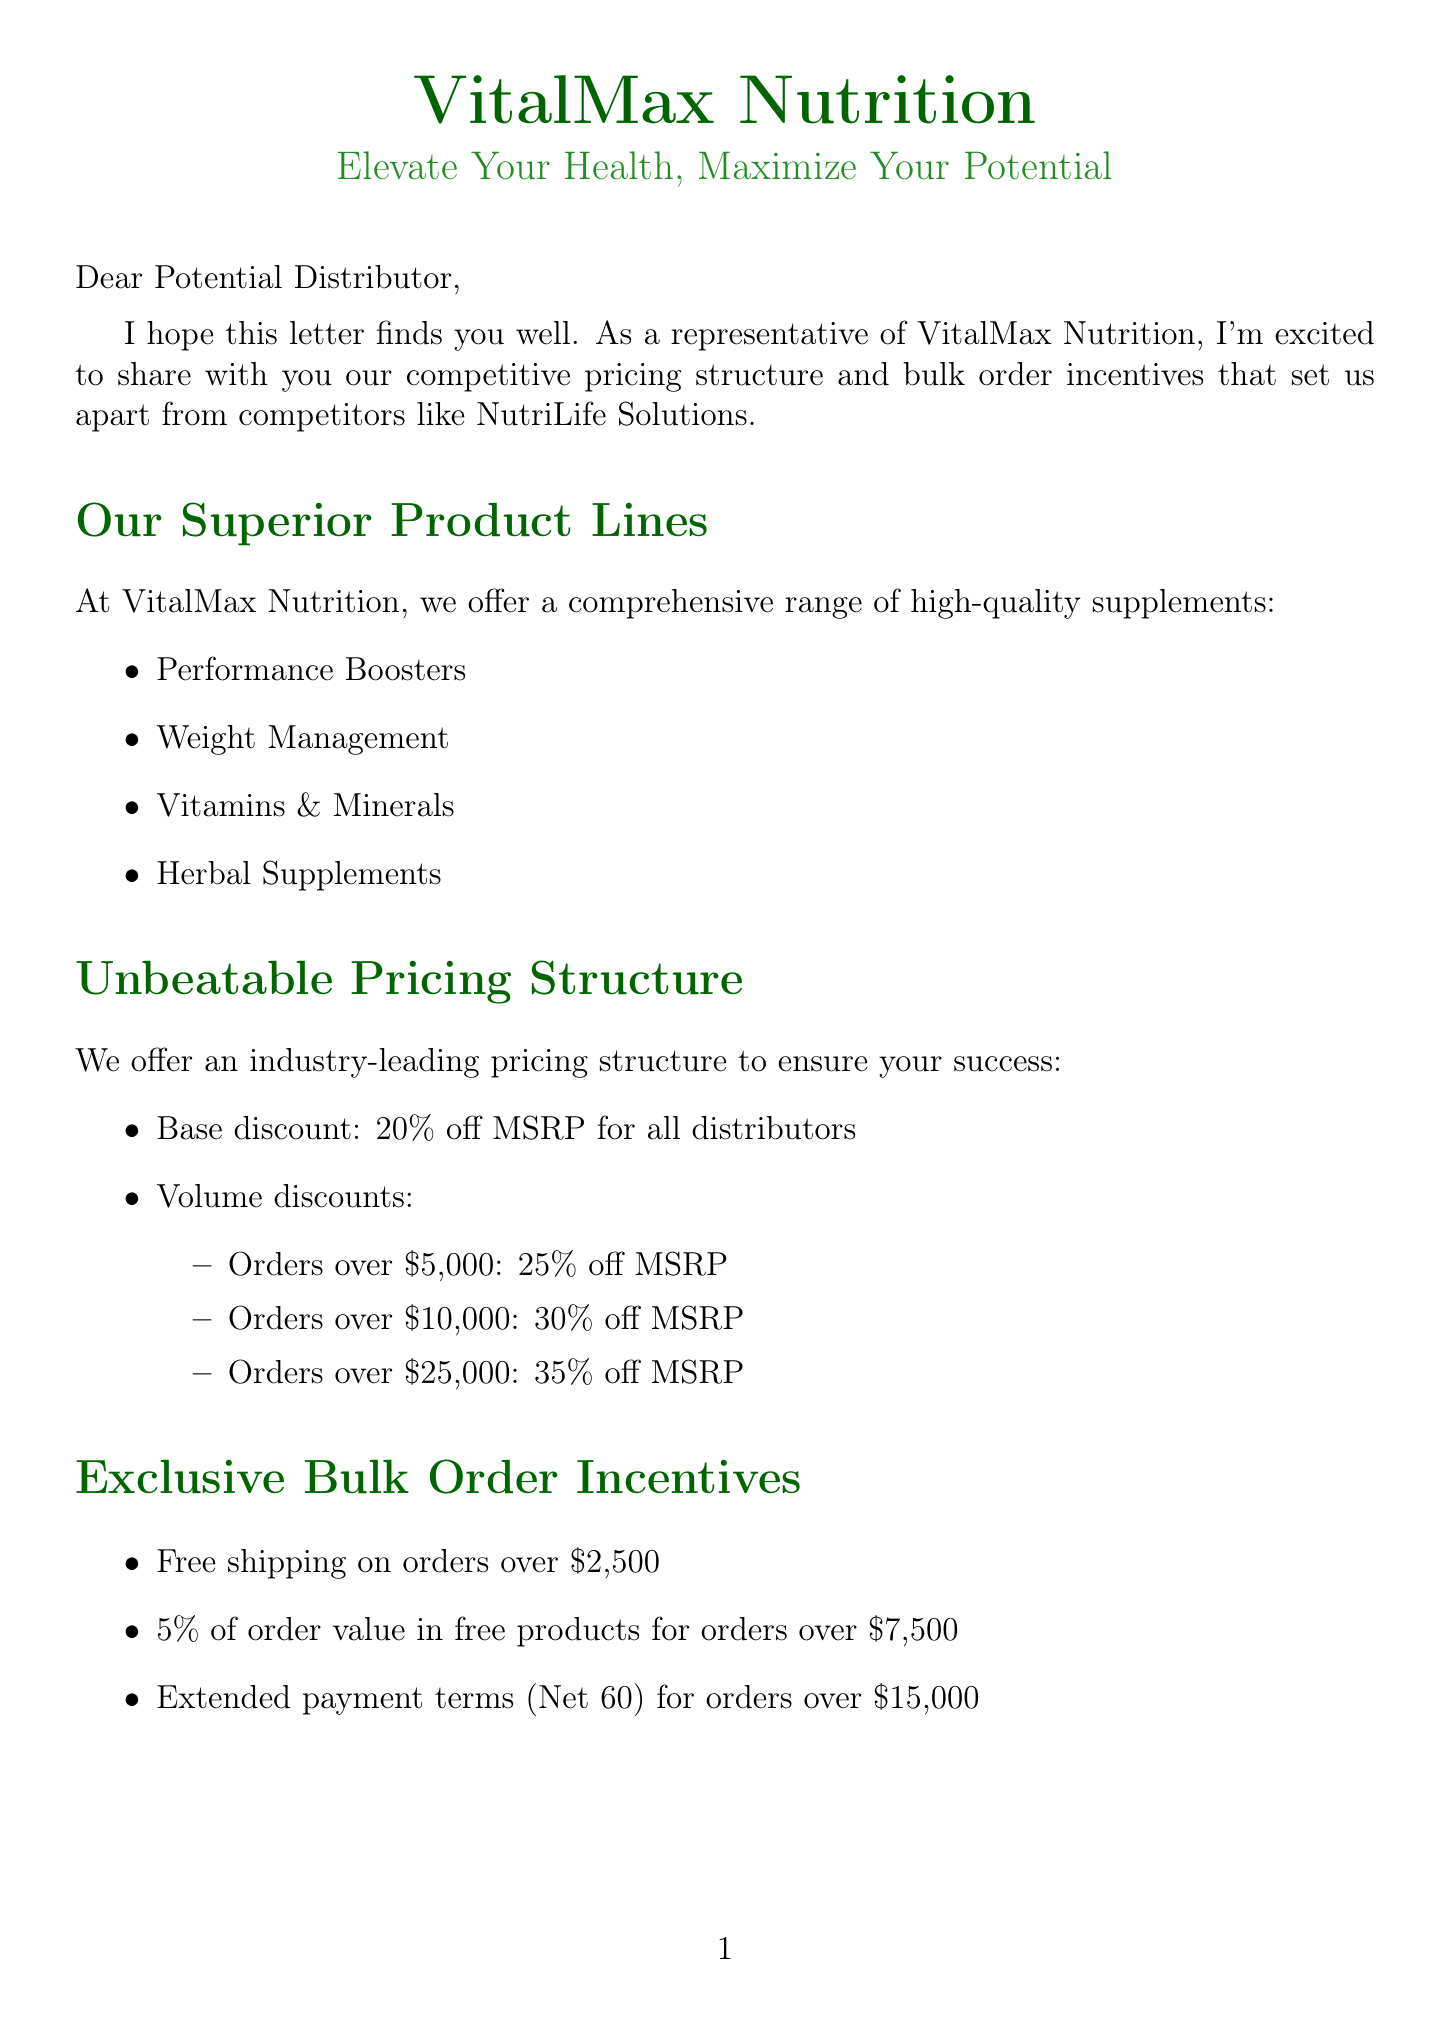What is the base discount for distributors? The base discount for all distributors is stated in the pricing structure section of the document.
Answer: 20% off MSRP What is the discount for orders over $10,000? The volume discounts section outlines the specific discounts based on order thresholds, including the one for over $10,000.
Answer: 30% off MSRP What is the threshold for free shipping? The bulk order incentives section mentions the specific amount that qualifies for free shipping.
Answer: Orders over $2,500 Who is the sales representative mentioned in the contact information? The document explicitly lists the sales representative's name in the contact information section.
Answer: Michael Chen What certification ensures products are tested by a third-party for purity and potency? The quality assurance section highlights the importance of certifications and testing, including the one that signifies third-party testing.
Answer: Eurofins Scientific Which product line is not listed in VitalMax Nutrition's offerings? By reasoning through the product lines mentioned, one can deduce which product line is absent that may be offered by competitors like NutriLife Solutions.
Answer: None of the mentioned product lines belong to NutriLife Solutions What percentage of order value is provided as bonus products for orders over $7,500? The document states the details for bulk order incentives, including bonus products.
Answer: 5% What is stated about sales performance since using VitalMax? The distributor testimonial provides insight into the sales performance after switching to VitalMax, detailing positive outcomes.
Answer: Increased by 30% What is the processing time for orders placed before 2 PM EST? The order fulfillment section describes the specific processing time for orders under certain conditions mentioned in the document.
Answer: Same-day processing 